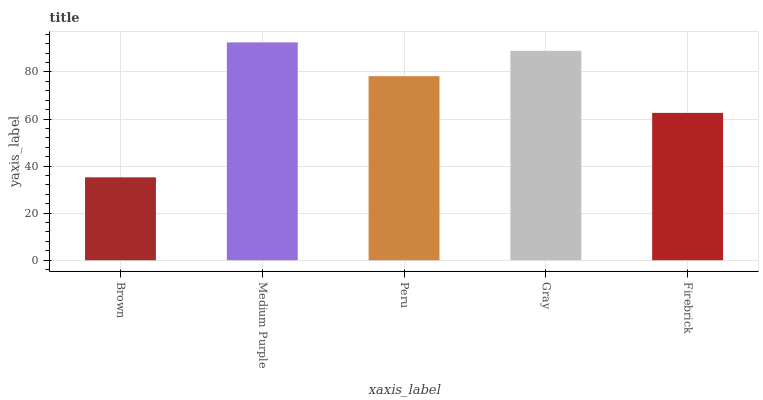Is Brown the minimum?
Answer yes or no. Yes. Is Medium Purple the maximum?
Answer yes or no. Yes. Is Peru the minimum?
Answer yes or no. No. Is Peru the maximum?
Answer yes or no. No. Is Medium Purple greater than Peru?
Answer yes or no. Yes. Is Peru less than Medium Purple?
Answer yes or no. Yes. Is Peru greater than Medium Purple?
Answer yes or no. No. Is Medium Purple less than Peru?
Answer yes or no. No. Is Peru the high median?
Answer yes or no. Yes. Is Peru the low median?
Answer yes or no. Yes. Is Gray the high median?
Answer yes or no. No. Is Firebrick the low median?
Answer yes or no. No. 